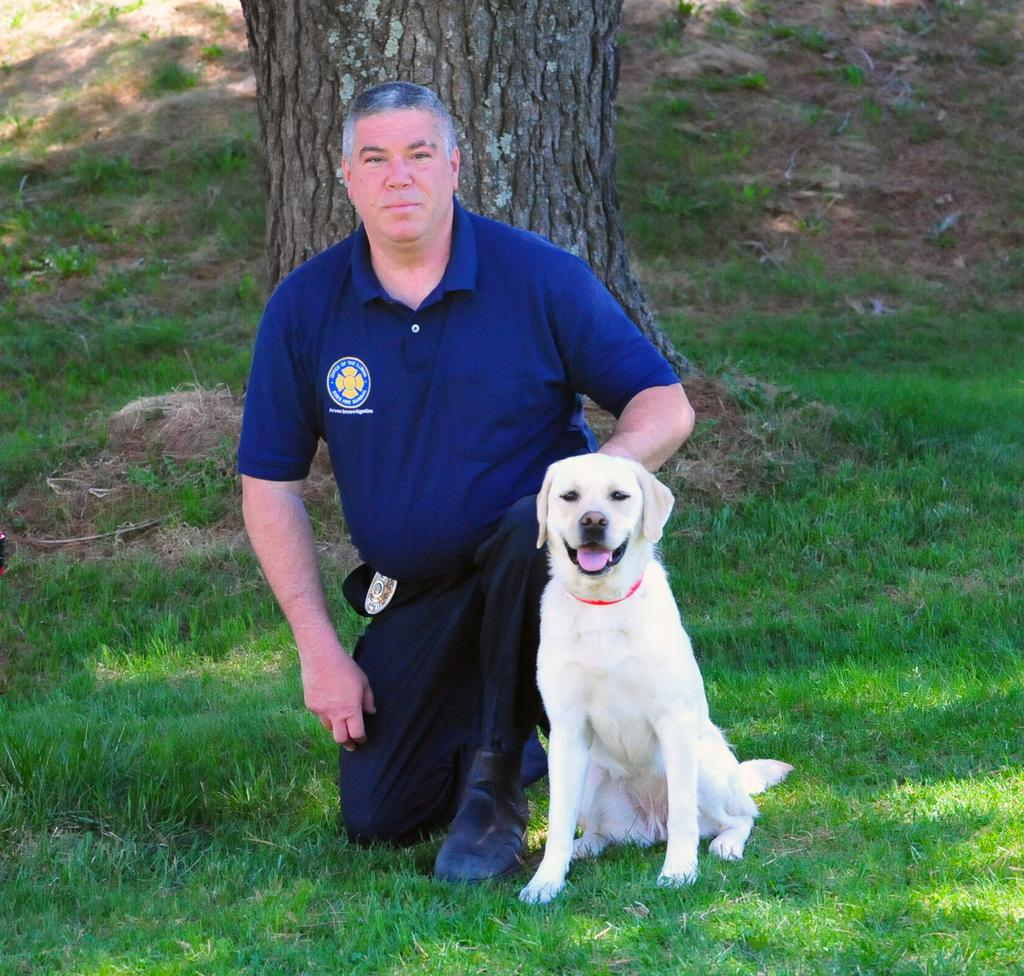Who is present in the image? There is a man in the image. What is the man wearing? The man is wearing a blue t-shirt. What position is the man in? The man is in a squat position. What else can be seen in the image? There is a dog in the image, and the dog is sitting on the grass. What else is visible in the image? There is a tree trunk visible in the image. What type of wrench is the man using to mark his territory in the image? There is no wrench present in the image, and the man is not marking his territory. 